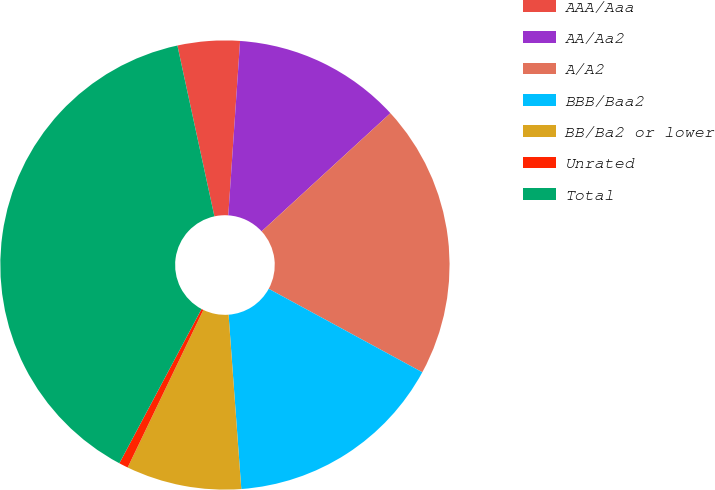<chart> <loc_0><loc_0><loc_500><loc_500><pie_chart><fcel>AAA/Aaa<fcel>AA/Aa2<fcel>A/A2<fcel>BBB/Baa2<fcel>BB/Ba2 or lower<fcel>Unrated<fcel>Total<nl><fcel>4.47%<fcel>12.11%<fcel>19.74%<fcel>15.92%<fcel>8.29%<fcel>0.66%<fcel>38.82%<nl></chart> 